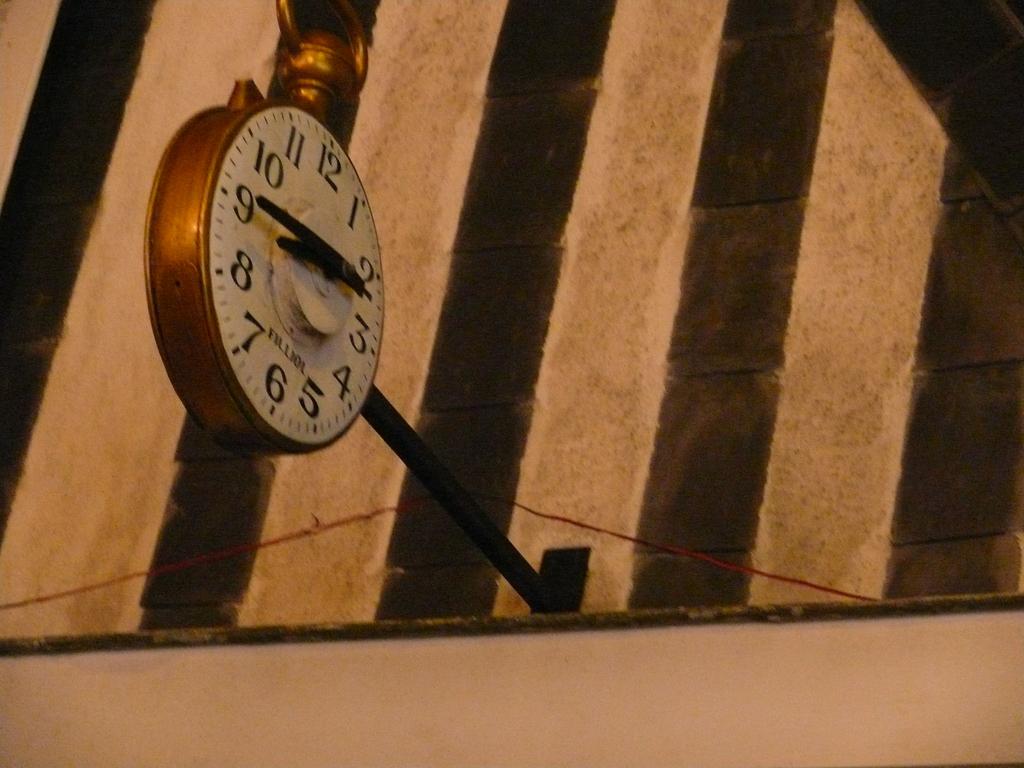What is the word above the 6?
Your answer should be compact. Filliol. 